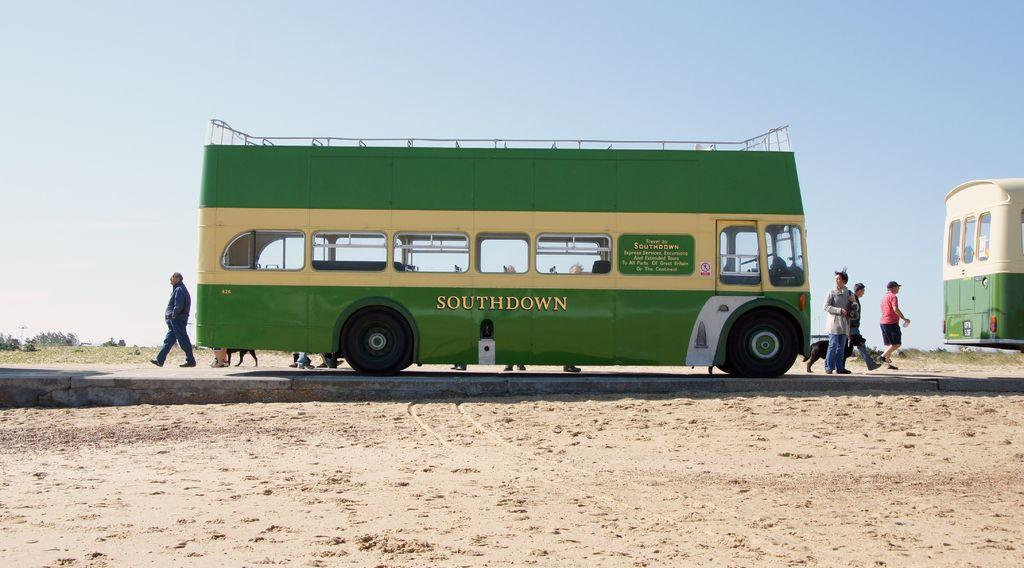How many buses are visible in the image? There are two buses in the image. What are the buses doing in the image? The buses are parked on the road. Are there any people present in the image? Yes, there are people walking on the road surface in the image. What type of tomatoes can be seen growing in the frame of the image? There are no tomatoes or frames present in the image; it features two buses parked on the road and people walking on the road surface. 